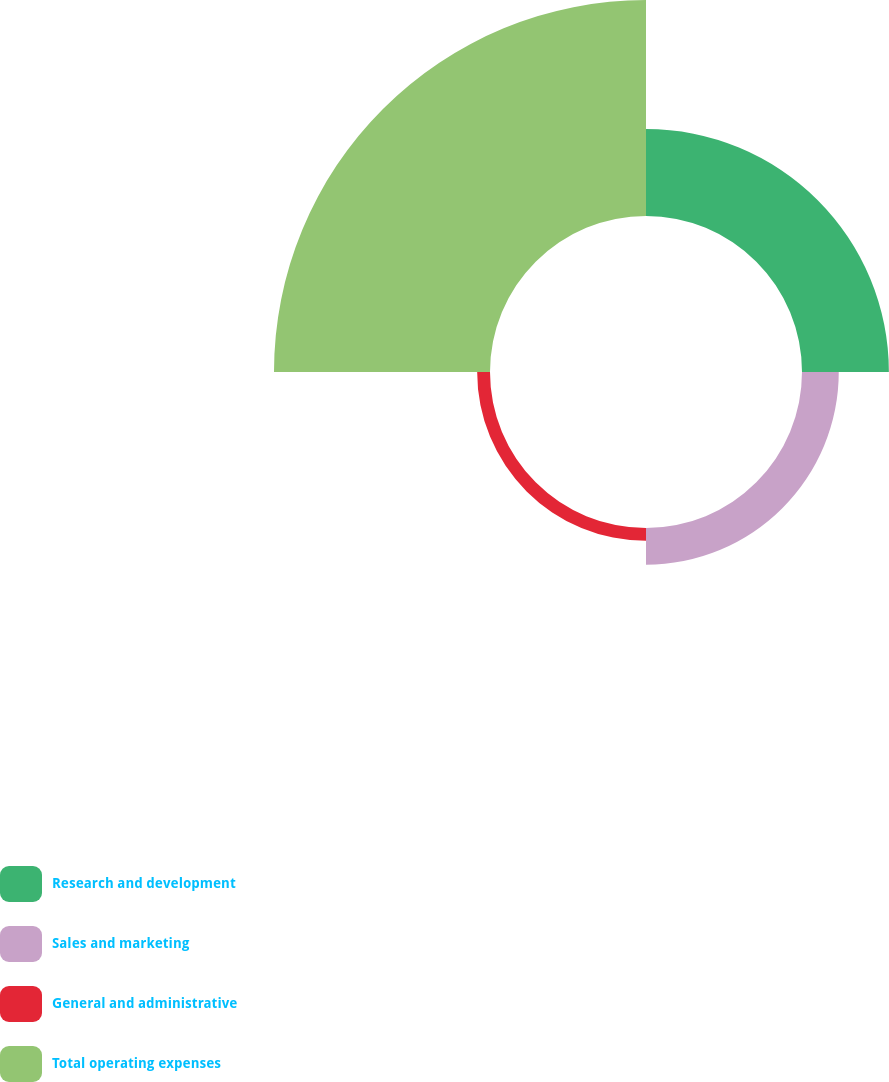<chart> <loc_0><loc_0><loc_500><loc_500><pie_chart><fcel>Research and development<fcel>Sales and marketing<fcel>General and administrative<fcel>Total operating expenses<nl><fcel>24.65%<fcel>10.43%<fcel>3.64%<fcel>61.28%<nl></chart> 